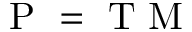Convert formula to latex. <formula><loc_0><loc_0><loc_500><loc_500>P = T M</formula> 